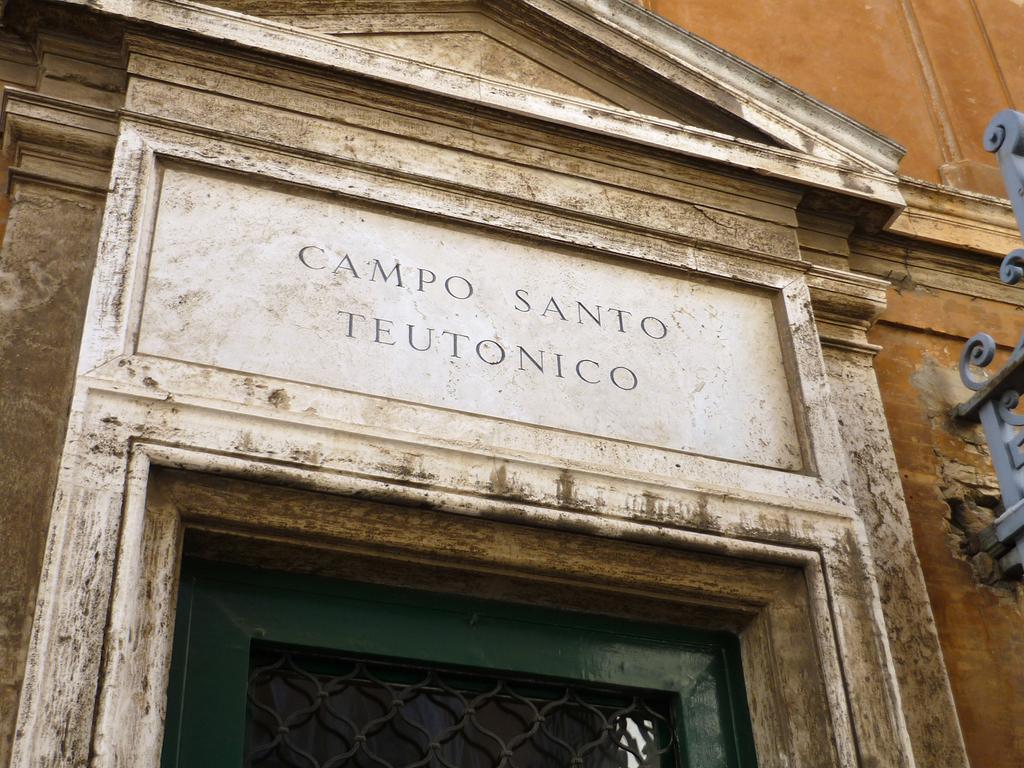How would you summarize this image in a sentence or two? In this picture we can see a building with a name on it. 